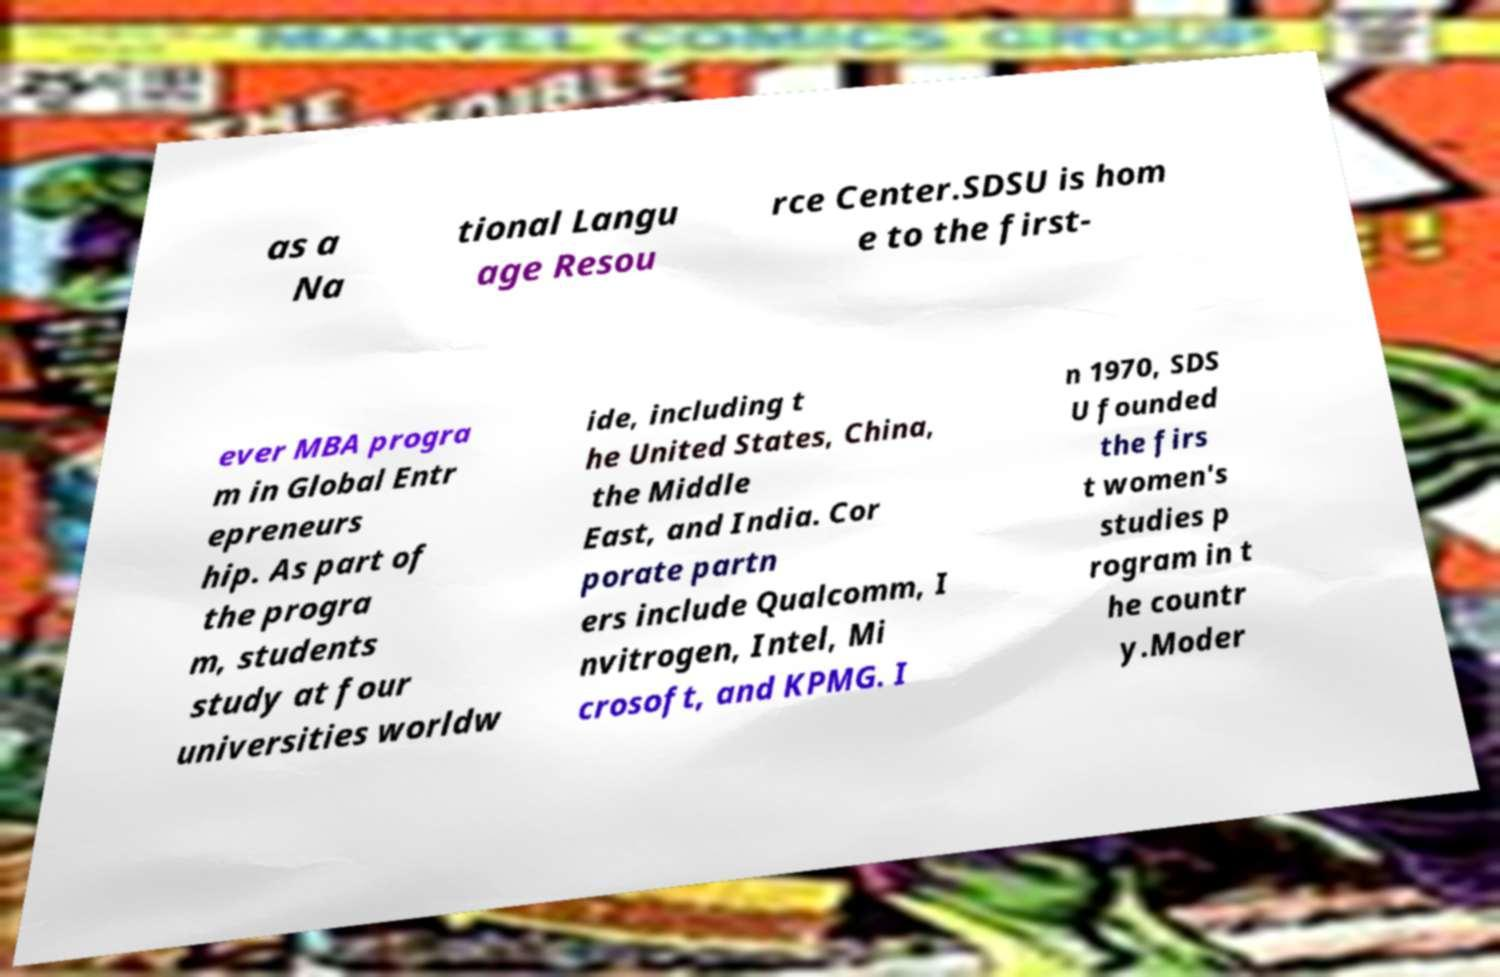I need the written content from this picture converted into text. Can you do that? as a Na tional Langu age Resou rce Center.SDSU is hom e to the first- ever MBA progra m in Global Entr epreneurs hip. As part of the progra m, students study at four universities worldw ide, including t he United States, China, the Middle East, and India. Cor porate partn ers include Qualcomm, I nvitrogen, Intel, Mi crosoft, and KPMG. I n 1970, SDS U founded the firs t women's studies p rogram in t he countr y.Moder 